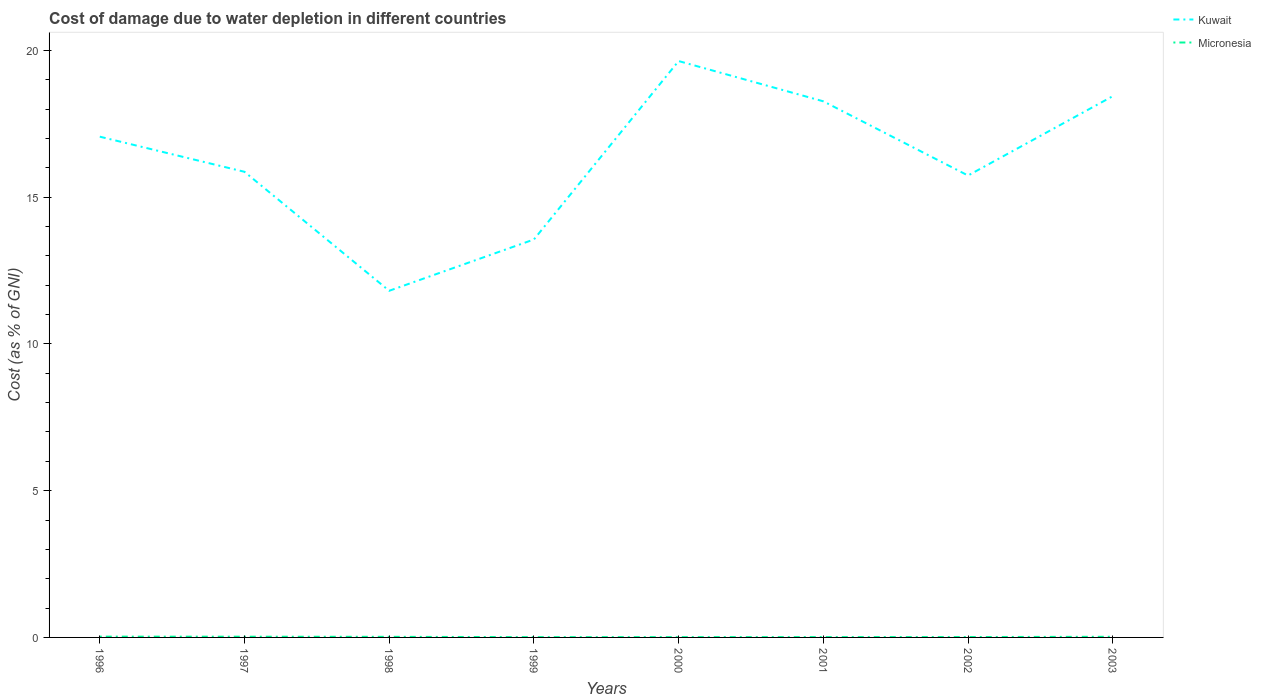Across all years, what is the maximum cost of damage caused due to water depletion in Kuwait?
Your response must be concise. 11.81. What is the total cost of damage caused due to water depletion in Micronesia in the graph?
Make the answer very short. -0. What is the difference between the highest and the second highest cost of damage caused due to water depletion in Micronesia?
Provide a short and direct response. 0.02. How many years are there in the graph?
Provide a short and direct response. 8. Does the graph contain any zero values?
Your response must be concise. No. Does the graph contain grids?
Your answer should be very brief. No. Where does the legend appear in the graph?
Offer a terse response. Top right. What is the title of the graph?
Provide a succinct answer. Cost of damage due to water depletion in different countries. What is the label or title of the X-axis?
Keep it short and to the point. Years. What is the label or title of the Y-axis?
Offer a very short reply. Cost (as % of GNI). What is the Cost (as % of GNI) in Kuwait in 1996?
Ensure brevity in your answer.  17.06. What is the Cost (as % of GNI) in Micronesia in 1996?
Provide a succinct answer. 0.03. What is the Cost (as % of GNI) in Kuwait in 1997?
Your answer should be very brief. 15.86. What is the Cost (as % of GNI) of Micronesia in 1997?
Offer a very short reply. 0.02. What is the Cost (as % of GNI) of Kuwait in 1998?
Your answer should be very brief. 11.81. What is the Cost (as % of GNI) of Micronesia in 1998?
Your response must be concise. 0.02. What is the Cost (as % of GNI) of Kuwait in 1999?
Offer a terse response. 13.56. What is the Cost (as % of GNI) in Micronesia in 1999?
Make the answer very short. 0.01. What is the Cost (as % of GNI) in Kuwait in 2000?
Offer a terse response. 19.64. What is the Cost (as % of GNI) in Micronesia in 2000?
Ensure brevity in your answer.  0.01. What is the Cost (as % of GNI) of Kuwait in 2001?
Offer a very short reply. 18.26. What is the Cost (as % of GNI) of Micronesia in 2001?
Your answer should be very brief. 0.01. What is the Cost (as % of GNI) of Kuwait in 2002?
Offer a terse response. 15.74. What is the Cost (as % of GNI) of Micronesia in 2002?
Make the answer very short. 0.01. What is the Cost (as % of GNI) of Kuwait in 2003?
Offer a terse response. 18.44. What is the Cost (as % of GNI) in Micronesia in 2003?
Provide a short and direct response. 0.02. Across all years, what is the maximum Cost (as % of GNI) in Kuwait?
Provide a succinct answer. 19.64. Across all years, what is the maximum Cost (as % of GNI) of Micronesia?
Provide a short and direct response. 0.03. Across all years, what is the minimum Cost (as % of GNI) of Kuwait?
Your answer should be compact. 11.81. Across all years, what is the minimum Cost (as % of GNI) in Micronesia?
Provide a succinct answer. 0.01. What is the total Cost (as % of GNI) in Kuwait in the graph?
Offer a very short reply. 130.36. What is the total Cost (as % of GNI) of Micronesia in the graph?
Offer a very short reply. 0.14. What is the difference between the Cost (as % of GNI) in Kuwait in 1996 and that in 1997?
Your answer should be compact. 1.2. What is the difference between the Cost (as % of GNI) in Micronesia in 1996 and that in 1997?
Your answer should be very brief. 0. What is the difference between the Cost (as % of GNI) of Kuwait in 1996 and that in 1998?
Offer a very short reply. 5.25. What is the difference between the Cost (as % of GNI) of Micronesia in 1996 and that in 1998?
Keep it short and to the point. 0.01. What is the difference between the Cost (as % of GNI) of Kuwait in 1996 and that in 1999?
Offer a terse response. 3.5. What is the difference between the Cost (as % of GNI) in Micronesia in 1996 and that in 1999?
Provide a succinct answer. 0.02. What is the difference between the Cost (as % of GNI) of Kuwait in 1996 and that in 2000?
Ensure brevity in your answer.  -2.58. What is the difference between the Cost (as % of GNI) of Micronesia in 1996 and that in 2000?
Your answer should be very brief. 0.02. What is the difference between the Cost (as % of GNI) in Kuwait in 1996 and that in 2001?
Give a very brief answer. -1.2. What is the difference between the Cost (as % of GNI) of Micronesia in 1996 and that in 2001?
Keep it short and to the point. 0.02. What is the difference between the Cost (as % of GNI) of Kuwait in 1996 and that in 2002?
Your response must be concise. 1.32. What is the difference between the Cost (as % of GNI) in Micronesia in 1996 and that in 2002?
Your answer should be compact. 0.01. What is the difference between the Cost (as % of GNI) in Kuwait in 1996 and that in 2003?
Ensure brevity in your answer.  -1.38. What is the difference between the Cost (as % of GNI) in Micronesia in 1996 and that in 2003?
Provide a succinct answer. 0. What is the difference between the Cost (as % of GNI) in Kuwait in 1997 and that in 1998?
Your answer should be compact. 4.05. What is the difference between the Cost (as % of GNI) of Micronesia in 1997 and that in 1998?
Offer a terse response. 0. What is the difference between the Cost (as % of GNI) in Kuwait in 1997 and that in 1999?
Offer a terse response. 2.31. What is the difference between the Cost (as % of GNI) of Micronesia in 1997 and that in 1999?
Your answer should be very brief. 0.01. What is the difference between the Cost (as % of GNI) of Kuwait in 1997 and that in 2000?
Offer a terse response. -3.77. What is the difference between the Cost (as % of GNI) in Micronesia in 1997 and that in 2000?
Provide a short and direct response. 0.01. What is the difference between the Cost (as % of GNI) in Kuwait in 1997 and that in 2001?
Keep it short and to the point. -2.4. What is the difference between the Cost (as % of GNI) in Micronesia in 1997 and that in 2001?
Offer a terse response. 0.01. What is the difference between the Cost (as % of GNI) of Kuwait in 1997 and that in 2002?
Your response must be concise. 0.13. What is the difference between the Cost (as % of GNI) of Micronesia in 1997 and that in 2002?
Your answer should be very brief. 0.01. What is the difference between the Cost (as % of GNI) of Kuwait in 1997 and that in 2003?
Give a very brief answer. -2.58. What is the difference between the Cost (as % of GNI) in Micronesia in 1997 and that in 2003?
Offer a very short reply. 0. What is the difference between the Cost (as % of GNI) in Kuwait in 1998 and that in 1999?
Make the answer very short. -1.75. What is the difference between the Cost (as % of GNI) in Micronesia in 1998 and that in 1999?
Make the answer very short. 0.01. What is the difference between the Cost (as % of GNI) in Kuwait in 1998 and that in 2000?
Provide a short and direct response. -7.83. What is the difference between the Cost (as % of GNI) in Micronesia in 1998 and that in 2000?
Offer a very short reply. 0.01. What is the difference between the Cost (as % of GNI) in Kuwait in 1998 and that in 2001?
Offer a terse response. -6.45. What is the difference between the Cost (as % of GNI) in Micronesia in 1998 and that in 2001?
Provide a succinct answer. 0.01. What is the difference between the Cost (as % of GNI) of Kuwait in 1998 and that in 2002?
Ensure brevity in your answer.  -3.93. What is the difference between the Cost (as % of GNI) in Micronesia in 1998 and that in 2002?
Ensure brevity in your answer.  0.01. What is the difference between the Cost (as % of GNI) of Kuwait in 1998 and that in 2003?
Your answer should be compact. -6.63. What is the difference between the Cost (as % of GNI) of Micronesia in 1998 and that in 2003?
Give a very brief answer. -0. What is the difference between the Cost (as % of GNI) of Kuwait in 1999 and that in 2000?
Make the answer very short. -6.08. What is the difference between the Cost (as % of GNI) in Micronesia in 1999 and that in 2000?
Ensure brevity in your answer.  -0. What is the difference between the Cost (as % of GNI) of Kuwait in 1999 and that in 2001?
Ensure brevity in your answer.  -4.71. What is the difference between the Cost (as % of GNI) in Micronesia in 1999 and that in 2001?
Offer a very short reply. -0. What is the difference between the Cost (as % of GNI) of Kuwait in 1999 and that in 2002?
Ensure brevity in your answer.  -2.18. What is the difference between the Cost (as % of GNI) of Micronesia in 1999 and that in 2002?
Ensure brevity in your answer.  -0. What is the difference between the Cost (as % of GNI) of Kuwait in 1999 and that in 2003?
Your answer should be very brief. -4.88. What is the difference between the Cost (as % of GNI) of Micronesia in 1999 and that in 2003?
Offer a very short reply. -0.01. What is the difference between the Cost (as % of GNI) in Kuwait in 2000 and that in 2001?
Offer a terse response. 1.37. What is the difference between the Cost (as % of GNI) in Micronesia in 2000 and that in 2001?
Offer a terse response. -0. What is the difference between the Cost (as % of GNI) in Kuwait in 2000 and that in 2002?
Provide a short and direct response. 3.9. What is the difference between the Cost (as % of GNI) of Micronesia in 2000 and that in 2002?
Your response must be concise. -0. What is the difference between the Cost (as % of GNI) of Kuwait in 2000 and that in 2003?
Offer a very short reply. 1.2. What is the difference between the Cost (as % of GNI) in Micronesia in 2000 and that in 2003?
Provide a short and direct response. -0.01. What is the difference between the Cost (as % of GNI) of Kuwait in 2001 and that in 2002?
Your answer should be compact. 2.53. What is the difference between the Cost (as % of GNI) in Micronesia in 2001 and that in 2002?
Offer a terse response. -0. What is the difference between the Cost (as % of GNI) in Kuwait in 2001 and that in 2003?
Ensure brevity in your answer.  -0.17. What is the difference between the Cost (as % of GNI) in Micronesia in 2001 and that in 2003?
Ensure brevity in your answer.  -0.01. What is the difference between the Cost (as % of GNI) in Kuwait in 2002 and that in 2003?
Offer a terse response. -2.7. What is the difference between the Cost (as % of GNI) in Micronesia in 2002 and that in 2003?
Your response must be concise. -0.01. What is the difference between the Cost (as % of GNI) of Kuwait in 1996 and the Cost (as % of GNI) of Micronesia in 1997?
Ensure brevity in your answer.  17.03. What is the difference between the Cost (as % of GNI) in Kuwait in 1996 and the Cost (as % of GNI) in Micronesia in 1998?
Provide a succinct answer. 17.04. What is the difference between the Cost (as % of GNI) of Kuwait in 1996 and the Cost (as % of GNI) of Micronesia in 1999?
Your answer should be very brief. 17.05. What is the difference between the Cost (as % of GNI) of Kuwait in 1996 and the Cost (as % of GNI) of Micronesia in 2000?
Give a very brief answer. 17.05. What is the difference between the Cost (as % of GNI) of Kuwait in 1996 and the Cost (as % of GNI) of Micronesia in 2001?
Your answer should be compact. 17.05. What is the difference between the Cost (as % of GNI) of Kuwait in 1996 and the Cost (as % of GNI) of Micronesia in 2002?
Your answer should be very brief. 17.05. What is the difference between the Cost (as % of GNI) in Kuwait in 1996 and the Cost (as % of GNI) in Micronesia in 2003?
Offer a terse response. 17.04. What is the difference between the Cost (as % of GNI) in Kuwait in 1997 and the Cost (as % of GNI) in Micronesia in 1998?
Keep it short and to the point. 15.84. What is the difference between the Cost (as % of GNI) in Kuwait in 1997 and the Cost (as % of GNI) in Micronesia in 1999?
Ensure brevity in your answer.  15.85. What is the difference between the Cost (as % of GNI) in Kuwait in 1997 and the Cost (as % of GNI) in Micronesia in 2000?
Ensure brevity in your answer.  15.85. What is the difference between the Cost (as % of GNI) of Kuwait in 1997 and the Cost (as % of GNI) of Micronesia in 2001?
Give a very brief answer. 15.85. What is the difference between the Cost (as % of GNI) of Kuwait in 1997 and the Cost (as % of GNI) of Micronesia in 2002?
Offer a terse response. 15.85. What is the difference between the Cost (as % of GNI) of Kuwait in 1997 and the Cost (as % of GNI) of Micronesia in 2003?
Offer a terse response. 15.84. What is the difference between the Cost (as % of GNI) in Kuwait in 1998 and the Cost (as % of GNI) in Micronesia in 1999?
Provide a short and direct response. 11.8. What is the difference between the Cost (as % of GNI) of Kuwait in 1998 and the Cost (as % of GNI) of Micronesia in 2000?
Ensure brevity in your answer.  11.8. What is the difference between the Cost (as % of GNI) of Kuwait in 1998 and the Cost (as % of GNI) of Micronesia in 2001?
Your answer should be very brief. 11.8. What is the difference between the Cost (as % of GNI) of Kuwait in 1998 and the Cost (as % of GNI) of Micronesia in 2002?
Keep it short and to the point. 11.8. What is the difference between the Cost (as % of GNI) in Kuwait in 1998 and the Cost (as % of GNI) in Micronesia in 2003?
Offer a terse response. 11.79. What is the difference between the Cost (as % of GNI) of Kuwait in 1999 and the Cost (as % of GNI) of Micronesia in 2000?
Provide a short and direct response. 13.55. What is the difference between the Cost (as % of GNI) of Kuwait in 1999 and the Cost (as % of GNI) of Micronesia in 2001?
Give a very brief answer. 13.55. What is the difference between the Cost (as % of GNI) in Kuwait in 1999 and the Cost (as % of GNI) in Micronesia in 2002?
Provide a succinct answer. 13.54. What is the difference between the Cost (as % of GNI) of Kuwait in 1999 and the Cost (as % of GNI) of Micronesia in 2003?
Keep it short and to the point. 13.54. What is the difference between the Cost (as % of GNI) in Kuwait in 2000 and the Cost (as % of GNI) in Micronesia in 2001?
Make the answer very short. 19.62. What is the difference between the Cost (as % of GNI) of Kuwait in 2000 and the Cost (as % of GNI) of Micronesia in 2002?
Ensure brevity in your answer.  19.62. What is the difference between the Cost (as % of GNI) of Kuwait in 2000 and the Cost (as % of GNI) of Micronesia in 2003?
Make the answer very short. 19.61. What is the difference between the Cost (as % of GNI) in Kuwait in 2001 and the Cost (as % of GNI) in Micronesia in 2002?
Give a very brief answer. 18.25. What is the difference between the Cost (as % of GNI) of Kuwait in 2001 and the Cost (as % of GNI) of Micronesia in 2003?
Provide a short and direct response. 18.24. What is the difference between the Cost (as % of GNI) in Kuwait in 2002 and the Cost (as % of GNI) in Micronesia in 2003?
Provide a succinct answer. 15.71. What is the average Cost (as % of GNI) of Kuwait per year?
Give a very brief answer. 16.3. What is the average Cost (as % of GNI) in Micronesia per year?
Give a very brief answer. 0.02. In the year 1996, what is the difference between the Cost (as % of GNI) in Kuwait and Cost (as % of GNI) in Micronesia?
Provide a succinct answer. 17.03. In the year 1997, what is the difference between the Cost (as % of GNI) of Kuwait and Cost (as % of GNI) of Micronesia?
Give a very brief answer. 15.84. In the year 1998, what is the difference between the Cost (as % of GNI) of Kuwait and Cost (as % of GNI) of Micronesia?
Your answer should be very brief. 11.79. In the year 1999, what is the difference between the Cost (as % of GNI) in Kuwait and Cost (as % of GNI) in Micronesia?
Offer a terse response. 13.55. In the year 2000, what is the difference between the Cost (as % of GNI) of Kuwait and Cost (as % of GNI) of Micronesia?
Give a very brief answer. 19.62. In the year 2001, what is the difference between the Cost (as % of GNI) of Kuwait and Cost (as % of GNI) of Micronesia?
Offer a very short reply. 18.25. In the year 2002, what is the difference between the Cost (as % of GNI) of Kuwait and Cost (as % of GNI) of Micronesia?
Provide a short and direct response. 15.72. In the year 2003, what is the difference between the Cost (as % of GNI) in Kuwait and Cost (as % of GNI) in Micronesia?
Keep it short and to the point. 18.42. What is the ratio of the Cost (as % of GNI) in Kuwait in 1996 to that in 1997?
Ensure brevity in your answer.  1.08. What is the ratio of the Cost (as % of GNI) in Micronesia in 1996 to that in 1997?
Your answer should be compact. 1.08. What is the ratio of the Cost (as % of GNI) in Kuwait in 1996 to that in 1998?
Offer a terse response. 1.44. What is the ratio of the Cost (as % of GNI) in Micronesia in 1996 to that in 1998?
Keep it short and to the point. 1.32. What is the ratio of the Cost (as % of GNI) of Kuwait in 1996 to that in 1999?
Your response must be concise. 1.26. What is the ratio of the Cost (as % of GNI) in Micronesia in 1996 to that in 1999?
Ensure brevity in your answer.  2.62. What is the ratio of the Cost (as % of GNI) in Kuwait in 1996 to that in 2000?
Give a very brief answer. 0.87. What is the ratio of the Cost (as % of GNI) of Micronesia in 1996 to that in 2000?
Provide a short and direct response. 2.46. What is the ratio of the Cost (as % of GNI) in Kuwait in 1996 to that in 2001?
Keep it short and to the point. 0.93. What is the ratio of the Cost (as % of GNI) of Micronesia in 1996 to that in 2001?
Your response must be concise. 2.29. What is the ratio of the Cost (as % of GNI) of Kuwait in 1996 to that in 2002?
Your answer should be compact. 1.08. What is the ratio of the Cost (as % of GNI) of Micronesia in 1996 to that in 2002?
Provide a succinct answer. 2.03. What is the ratio of the Cost (as % of GNI) of Kuwait in 1996 to that in 2003?
Ensure brevity in your answer.  0.93. What is the ratio of the Cost (as % of GNI) in Micronesia in 1996 to that in 2003?
Provide a succinct answer. 1.22. What is the ratio of the Cost (as % of GNI) of Kuwait in 1997 to that in 1998?
Offer a very short reply. 1.34. What is the ratio of the Cost (as % of GNI) of Micronesia in 1997 to that in 1998?
Give a very brief answer. 1.22. What is the ratio of the Cost (as % of GNI) in Kuwait in 1997 to that in 1999?
Offer a terse response. 1.17. What is the ratio of the Cost (as % of GNI) of Micronesia in 1997 to that in 1999?
Provide a short and direct response. 2.42. What is the ratio of the Cost (as % of GNI) of Kuwait in 1997 to that in 2000?
Keep it short and to the point. 0.81. What is the ratio of the Cost (as % of GNI) of Micronesia in 1997 to that in 2000?
Offer a terse response. 2.27. What is the ratio of the Cost (as % of GNI) of Kuwait in 1997 to that in 2001?
Ensure brevity in your answer.  0.87. What is the ratio of the Cost (as % of GNI) in Micronesia in 1997 to that in 2001?
Offer a very short reply. 2.12. What is the ratio of the Cost (as % of GNI) of Kuwait in 1997 to that in 2002?
Give a very brief answer. 1.01. What is the ratio of the Cost (as % of GNI) in Micronesia in 1997 to that in 2002?
Offer a terse response. 1.88. What is the ratio of the Cost (as % of GNI) in Kuwait in 1997 to that in 2003?
Your answer should be very brief. 0.86. What is the ratio of the Cost (as % of GNI) in Micronesia in 1997 to that in 2003?
Your answer should be very brief. 1.13. What is the ratio of the Cost (as % of GNI) of Kuwait in 1998 to that in 1999?
Keep it short and to the point. 0.87. What is the ratio of the Cost (as % of GNI) in Micronesia in 1998 to that in 1999?
Offer a very short reply. 1.99. What is the ratio of the Cost (as % of GNI) of Kuwait in 1998 to that in 2000?
Keep it short and to the point. 0.6. What is the ratio of the Cost (as % of GNI) in Micronesia in 1998 to that in 2000?
Your answer should be very brief. 1.86. What is the ratio of the Cost (as % of GNI) of Kuwait in 1998 to that in 2001?
Your answer should be very brief. 0.65. What is the ratio of the Cost (as % of GNI) of Micronesia in 1998 to that in 2001?
Offer a very short reply. 1.74. What is the ratio of the Cost (as % of GNI) of Kuwait in 1998 to that in 2002?
Offer a terse response. 0.75. What is the ratio of the Cost (as % of GNI) in Micronesia in 1998 to that in 2002?
Make the answer very short. 1.54. What is the ratio of the Cost (as % of GNI) of Kuwait in 1998 to that in 2003?
Give a very brief answer. 0.64. What is the ratio of the Cost (as % of GNI) of Micronesia in 1998 to that in 2003?
Give a very brief answer. 0.92. What is the ratio of the Cost (as % of GNI) in Kuwait in 1999 to that in 2000?
Ensure brevity in your answer.  0.69. What is the ratio of the Cost (as % of GNI) of Micronesia in 1999 to that in 2000?
Offer a very short reply. 0.94. What is the ratio of the Cost (as % of GNI) in Kuwait in 1999 to that in 2001?
Ensure brevity in your answer.  0.74. What is the ratio of the Cost (as % of GNI) in Micronesia in 1999 to that in 2001?
Provide a short and direct response. 0.87. What is the ratio of the Cost (as % of GNI) of Kuwait in 1999 to that in 2002?
Your answer should be compact. 0.86. What is the ratio of the Cost (as % of GNI) of Micronesia in 1999 to that in 2002?
Provide a short and direct response. 0.77. What is the ratio of the Cost (as % of GNI) of Kuwait in 1999 to that in 2003?
Provide a short and direct response. 0.74. What is the ratio of the Cost (as % of GNI) of Micronesia in 1999 to that in 2003?
Provide a short and direct response. 0.46. What is the ratio of the Cost (as % of GNI) of Kuwait in 2000 to that in 2001?
Your answer should be compact. 1.08. What is the ratio of the Cost (as % of GNI) in Micronesia in 2000 to that in 2001?
Keep it short and to the point. 0.93. What is the ratio of the Cost (as % of GNI) in Kuwait in 2000 to that in 2002?
Give a very brief answer. 1.25. What is the ratio of the Cost (as % of GNI) in Micronesia in 2000 to that in 2002?
Make the answer very short. 0.82. What is the ratio of the Cost (as % of GNI) of Kuwait in 2000 to that in 2003?
Offer a terse response. 1.06. What is the ratio of the Cost (as % of GNI) in Micronesia in 2000 to that in 2003?
Keep it short and to the point. 0.49. What is the ratio of the Cost (as % of GNI) in Kuwait in 2001 to that in 2002?
Provide a short and direct response. 1.16. What is the ratio of the Cost (as % of GNI) of Micronesia in 2001 to that in 2002?
Give a very brief answer. 0.89. What is the ratio of the Cost (as % of GNI) of Kuwait in 2001 to that in 2003?
Offer a very short reply. 0.99. What is the ratio of the Cost (as % of GNI) in Micronesia in 2001 to that in 2003?
Provide a short and direct response. 0.53. What is the ratio of the Cost (as % of GNI) of Kuwait in 2002 to that in 2003?
Keep it short and to the point. 0.85. What is the ratio of the Cost (as % of GNI) of Micronesia in 2002 to that in 2003?
Ensure brevity in your answer.  0.6. What is the difference between the highest and the second highest Cost (as % of GNI) of Kuwait?
Provide a short and direct response. 1.2. What is the difference between the highest and the second highest Cost (as % of GNI) of Micronesia?
Your answer should be very brief. 0. What is the difference between the highest and the lowest Cost (as % of GNI) in Kuwait?
Keep it short and to the point. 7.83. What is the difference between the highest and the lowest Cost (as % of GNI) of Micronesia?
Offer a very short reply. 0.02. 